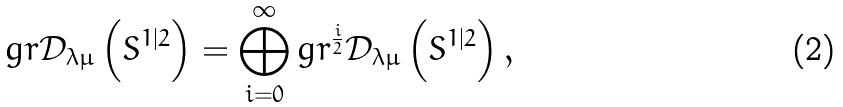Convert formula to latex. <formula><loc_0><loc_0><loc_500><loc_500>g r \mathcal { D } _ { \lambda \mu } \left ( S ^ { 1 | 2 } \right ) = \bigoplus _ { i = 0 } ^ { \infty } g r ^ { \frac { i } { 2 } } \mathcal { D } _ { \lambda \mu } \left ( S ^ { 1 | 2 } \right ) ,</formula> 